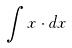Convert formula to latex. <formula><loc_0><loc_0><loc_500><loc_500>\int x \cdot d x</formula> 